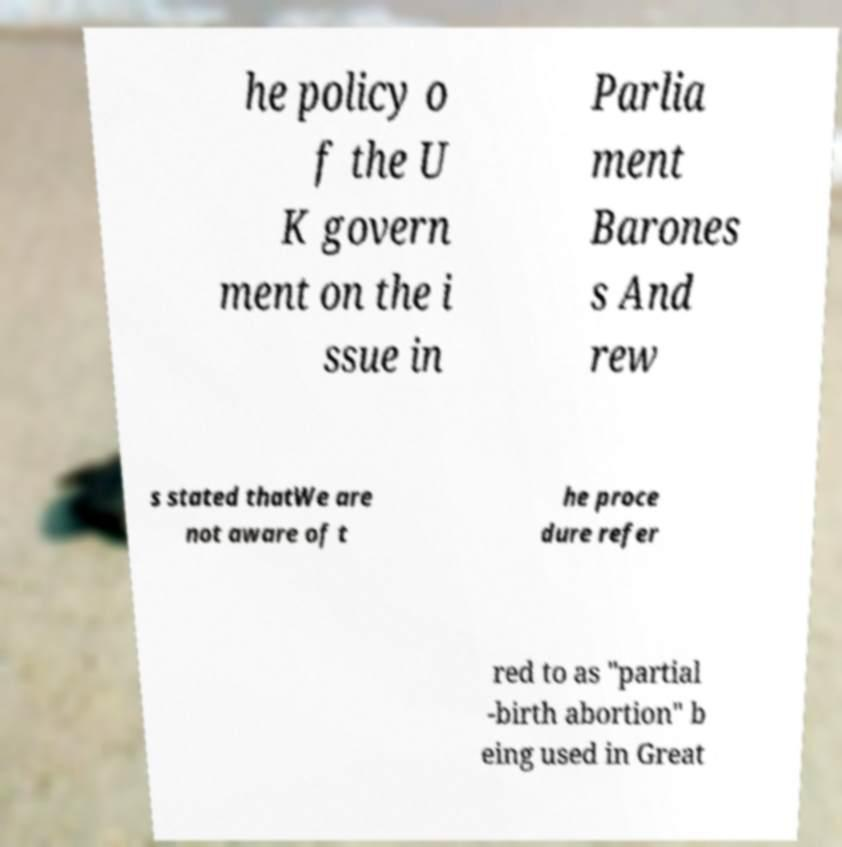I need the written content from this picture converted into text. Can you do that? he policy o f the U K govern ment on the i ssue in Parlia ment Barones s And rew s stated thatWe are not aware of t he proce dure refer red to as "partial -birth abortion" b eing used in Great 